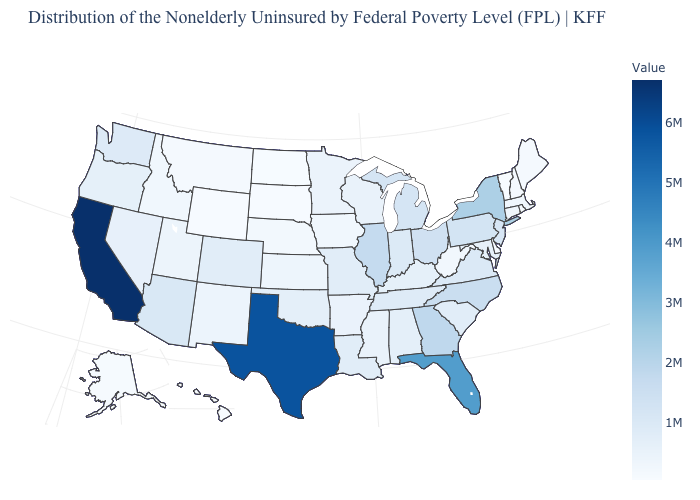Which states have the highest value in the USA?
Keep it brief. California. Among the states that border Virginia , which have the highest value?
Short answer required. North Carolina. Does Louisiana have a lower value than Hawaii?
Quick response, please. No. Does South Carolina have the highest value in the South?
Answer briefly. No. 